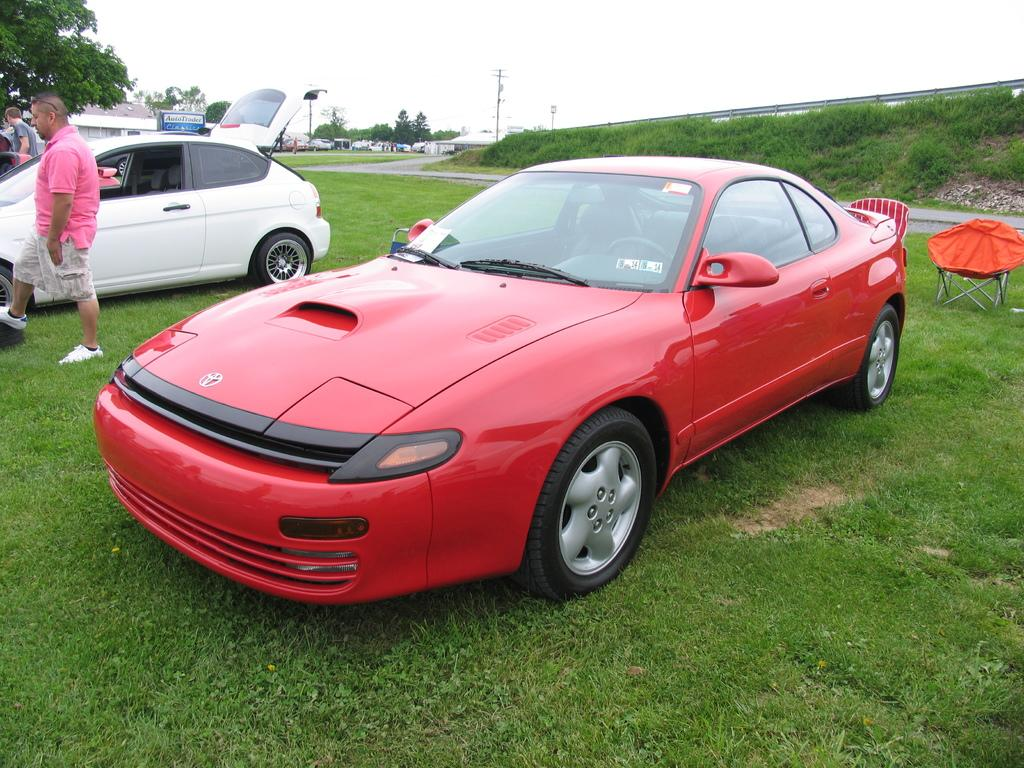What type of vehicle is in the foreground of the image? There is a red car in the foreground of the image. Can you describe another vehicle in the image? There is a white car on the left side of the image. Are there any people visible in the image? Yes, a person is standing on the left side of the image. How many thumbs can be seen on the person's hands in the image? There is no information about the person's hands or thumbs in the image, so we cannot determine the number of thumbs. 